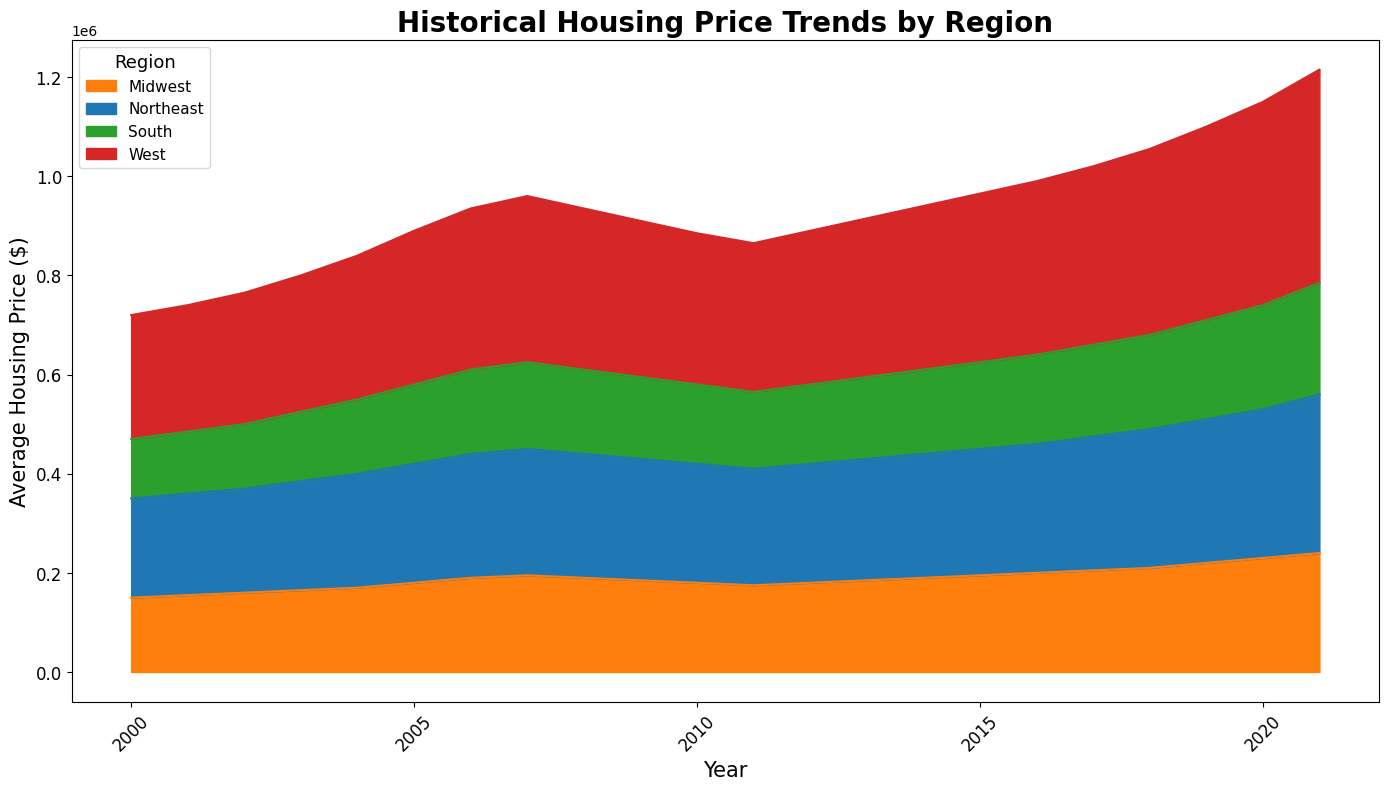What's the trend in the average housing prices for the Northeast region from 2000 to 2021? The average housing prices in the Northeast region show a general upward trend, starting at $200,000 in 2000 and increasing to $320,000 by 2021, with minor fluctuations in between, notably a decrease around 2008-2012.
Answer: Upward trend Which region had the highest housing prices in 2021? The West region had the highest housing prices in 2021, visually indicated by the topmost position in the area chart for that year.
Answer: West Between 2008 and 2011, which region experienced a decline in housing prices? The Northeast, Midwest, South, and West regions all experienced declines in housing prices between 2008 and 2011, as indicated by the downward slopes in their respective areas during those years.
Answer: Northeast, Midwest, South, and West Compare the housing price trends of the Midwest and South regions between 2000 and 2021. Both the Midwest and South regions exhibit an overall increase in housing prices, with the South starting at $120,000 and rising to $225,000, while the Midwest starts at $150,000 and rises to $240,000. The Midwest region has steeper increases compared to the South.
Answer: Both increase, Midwest steeper What is the combined average housing price for all regions in 2005? In 2005, the housing prices for the regions were: Northeast $240,000, Midwest $180,000, South $160,000, and West $310,000. Adding these and dividing by 4 gives the combined average: (240,000 + 180,000 + 160,000 + 310,000) / 4 = $222,500.
Answer: $222,500 In which year did the South region first reach an average housing price of at least $200,000? The South region first reached an average housing price of at least $200,000 in 2019, as seen from the plot.
Answer: 2019 What is the difference in average housing prices between the West and South regions in 2020? In 2020, the average housing prices were $410,000 for the West and $210,000 for the South. The difference is 410,000 - 210,000 = $200,000.
Answer: $200,000 Which region had the slowest growth in housing prices from 2000 to 2021? The South region had the slowest growth in housing prices, starting at $120,000 in 2000 and reaching $225,000 in 2021, which is a smaller increase compared to other regions.
Answer: South In which year did the Northeast region's housing prices peak before 2020? The Northeast region's housing prices peaked at $255,000 in 2007 before 2020, as indicated by the plot.
Answer: 2007 How did the housing prices for the Northeast region change from 2015 to 2021? The housing prices in the Northeast region increased from $255,000 in 2015 to $320,000 in 2021, indicating a rise in prices.
Answer: Increase 